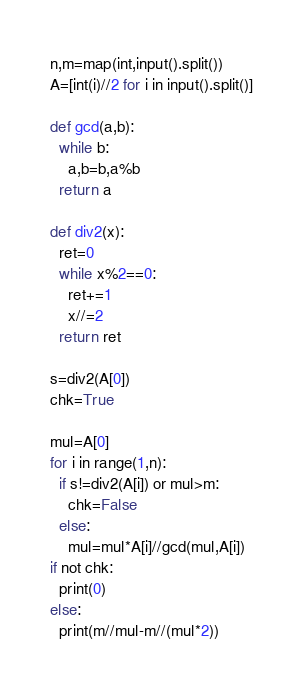Convert code to text. <code><loc_0><loc_0><loc_500><loc_500><_Python_>n,m=map(int,input().split())
A=[int(i)//2 for i in input().split()]

def gcd(a,b):
  while b:
    a,b=b,a%b
  return a

def div2(x):
  ret=0
  while x%2==0:
    ret+=1
    x//=2
  return ret

s=div2(A[0])
chk=True

mul=A[0]
for i in range(1,n):
  if s!=div2(A[i]) or mul>m:
    chk=False
  else:
    mul=mul*A[i]//gcd(mul,A[i])
if not chk:
  print(0)
else:
  print(m//mul-m//(mul*2))</code> 